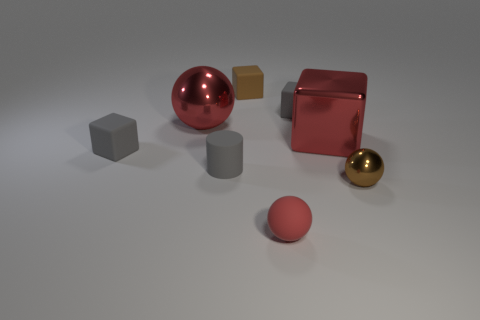There is a gray block on the left side of the cylinder; is its size the same as the metallic sphere that is to the left of the small red matte ball?
Your answer should be compact. No. There is a tiny brown thing in front of the tiny brown object that is behind the brown metallic object; what shape is it?
Provide a short and direct response. Sphere. How many other things have the same size as the red rubber object?
Your response must be concise. 5. Is there a big red metallic block?
Ensure brevity in your answer.  Yes. Is there any other thing that has the same color as the matte cylinder?
Ensure brevity in your answer.  Yes. The large object that is the same material as the large red ball is what shape?
Make the answer very short. Cube. The matte object in front of the brown shiny ball that is on the right side of the tiny ball in front of the brown metallic ball is what color?
Your answer should be compact. Red. Are there the same number of small brown objects that are behind the brown sphere and tiny red matte spheres?
Your answer should be compact. Yes. Is there anything else that has the same material as the small red object?
Your response must be concise. Yes. Is the color of the large shiny ball the same as the metallic object in front of the gray rubber cylinder?
Provide a succinct answer. No. 